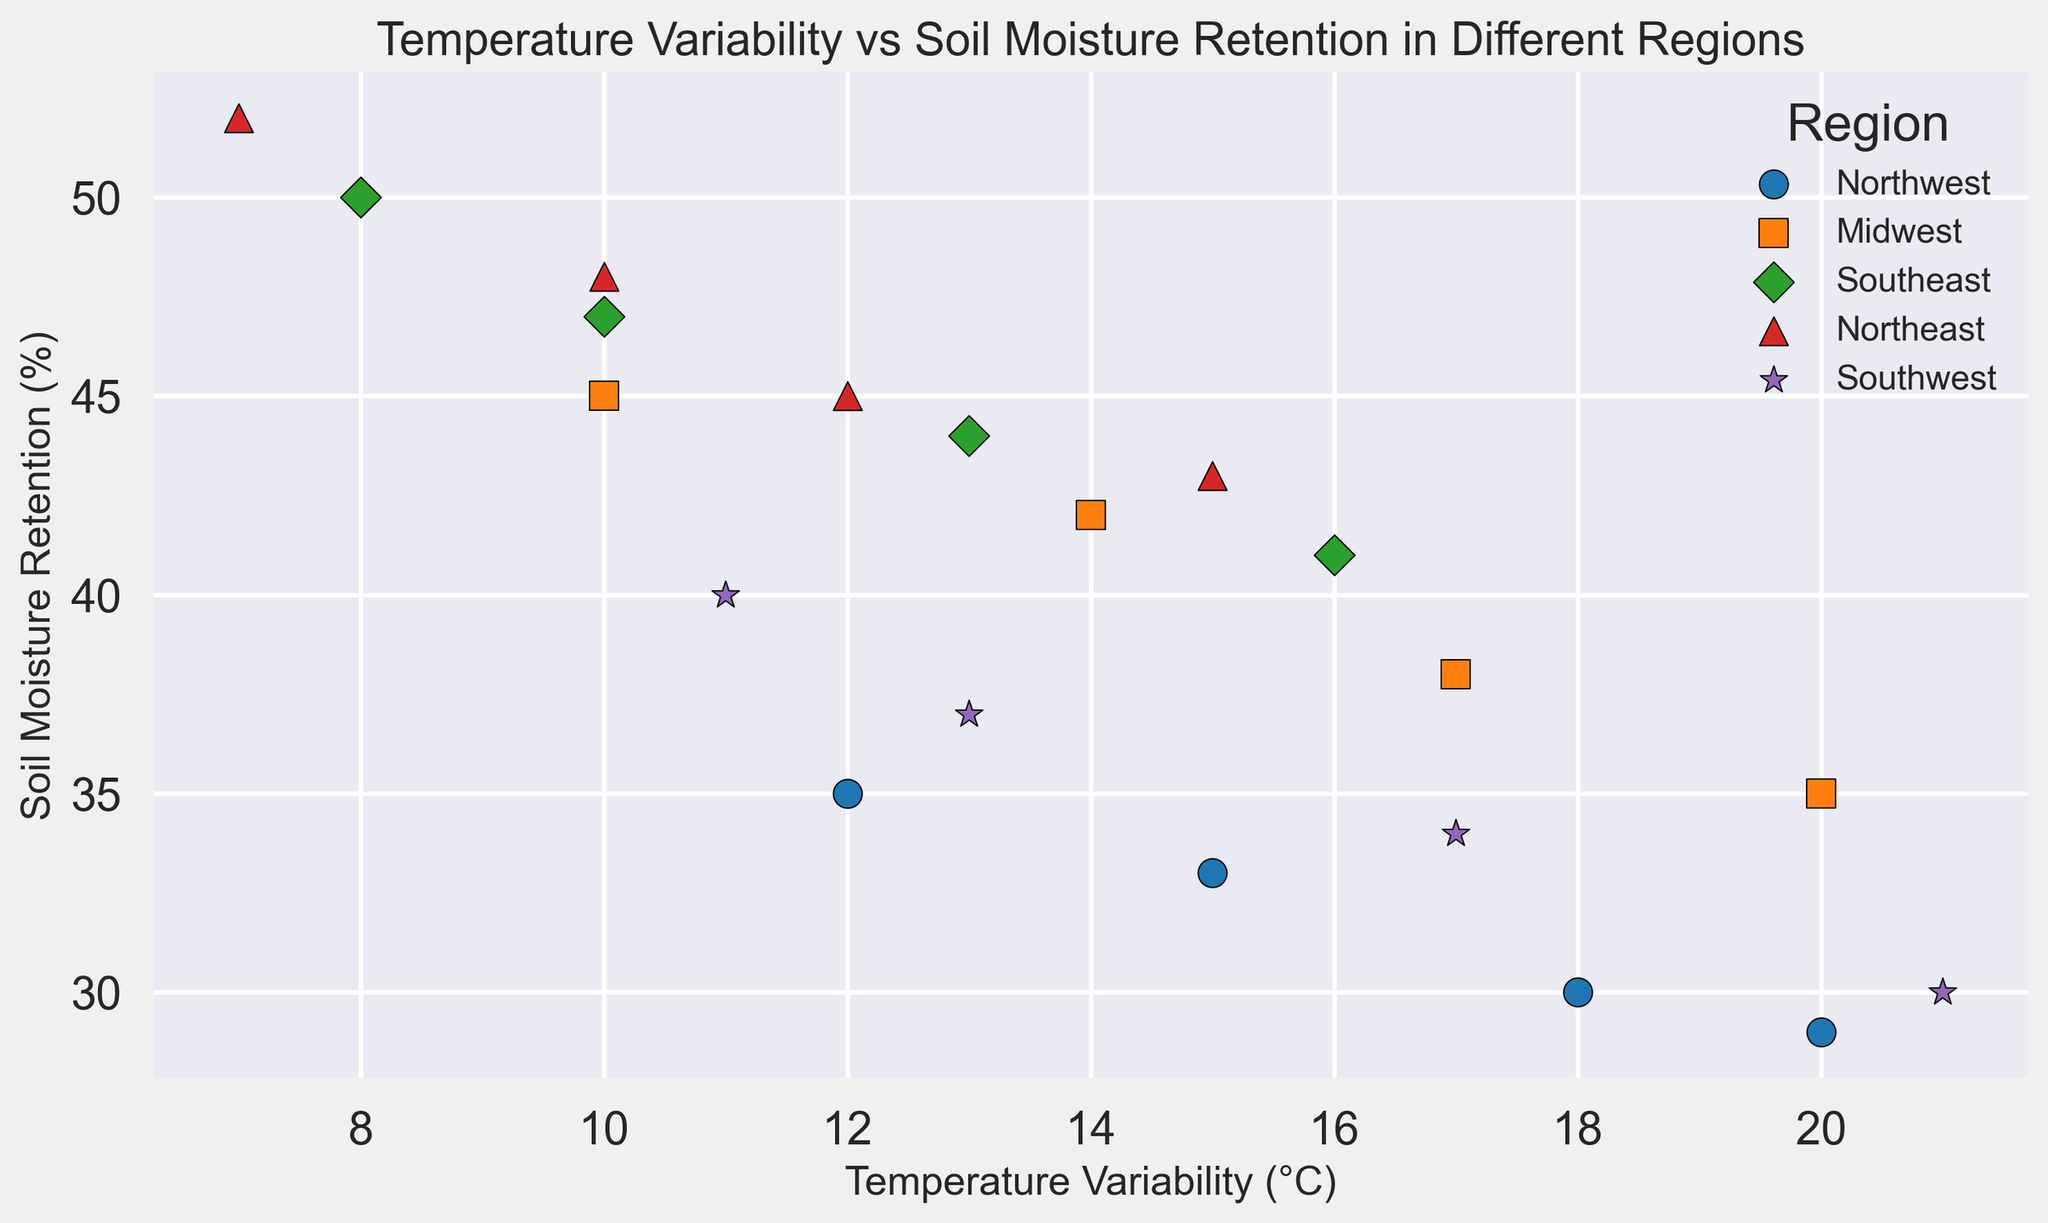What's the largest difference in soil moisture retention between any two regions at the same temperature variability? Look for points at the same temperature variability in different regions and calculate the difference in soil moisture retention. For example, at 20°C, the difference between Northwest (29%) and Midwest (35%) is 6%.
Answer: 6% Which region shows the highest soil moisture retention? Identify the highest point on the y-axis and check its corresponding region. The Northeast has the highest value at 52%.
Answer: Northeast Do any regions have overlapping temperature variability ranges? Check the x-axis ranges for each region and see if any regions share temperature variability values. For example, both the Northwest and Southwest range from 11°C to 21°C.
Answer: Yes Which region has the steepest decline in soil moisture retention as temperature variability increases? Compare the slopes of the points for each region. The Northwest region drops from 35% to 29% as temperature variability increases from 12°C to 20°C.
Answer: Northwest What is the average soil moisture retention in the Southeast region? Sum the soil moisture retention percentages of the Southeast points and divide by the number of points: (50 + 47 + 44 + 41) / 4 = 45.5%.
Answer: 45.5% Which region has the lowest soil moisture retention at 13°C temperature variability? Check the y-axis values at 13°C for all regions. The Southwest is at 37% and is the lowest.
Answer: Southwest How does the soil moisture retention in the Midwest at 14°C compare to the Northeast at 15°C? Find the corresponding values on the y-axis: the Midwest at 14°C is 42%, and the Northeast at 15°C is 43%. The Midwest has a slightly lower value.
Answer: Midwest is lower If you were to linearly interpolate, what would be the estimated soil moisture retention for the Southeast at 12°C temperature variability? Calculate an average value between those known at close temperatures: (47 + 44) / 2 = 45.5%.
Answer: 45.5% What's the temperature variability range for the Northeast region? Identify the minimum and maximum temperature values for the Northeast region, which range from 7°C to 15°C.
Answer: 7-15°C 